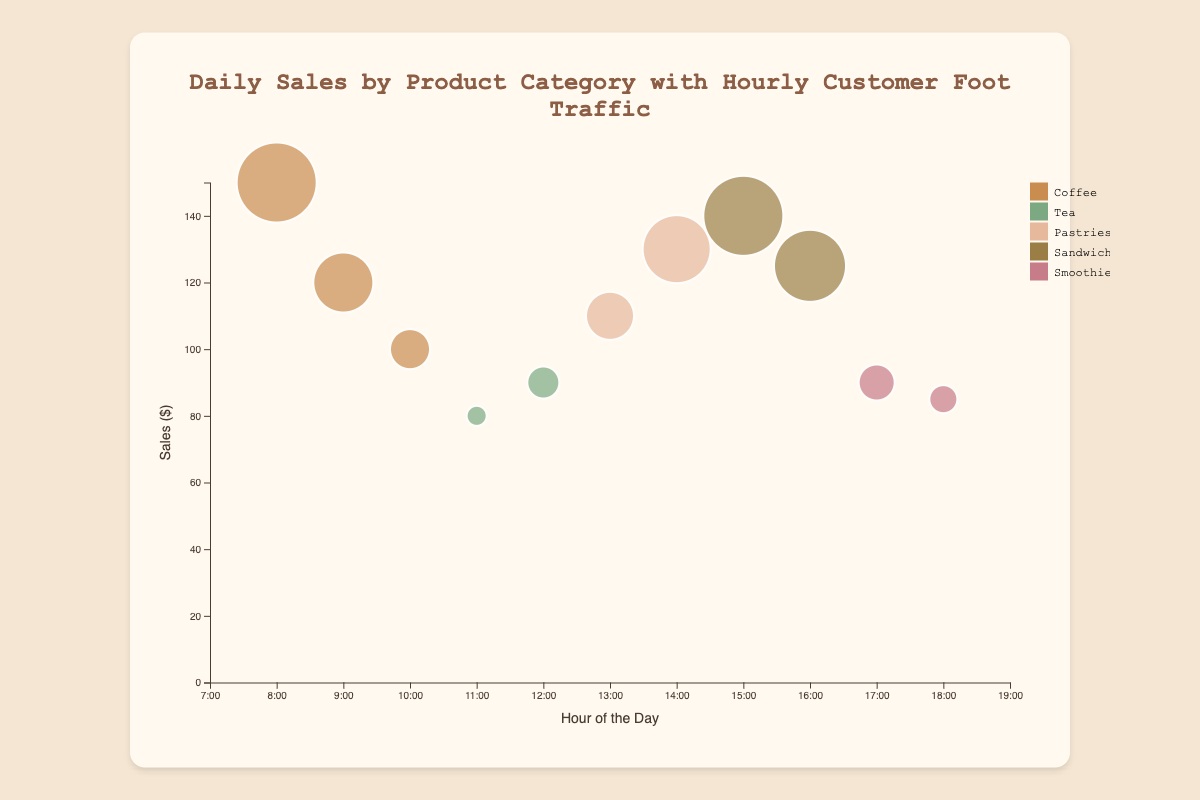What is the title of the chart? The title is usually located at the top of the chart and summarizes what the chart represents.
Answer: Daily Sales by Product Category with Hourly Customer Foot Traffic What does the horizontal axis represent? The horizontal axis at the bottom of the chart labels the data points on that axis. We can see it represents the hours of the day, ranging from 7:00 to 19:00.
Answer: Hour of the Day How many product categories are shown in the chart? By checking the legend on the right side of the chart, which lists the distinct categories, we see there are five different categories.
Answer: 5 In which hour did the highest sales occur, and which product was it for? By identifying the largest bubble along the vertical axis representing sales, at hour 8:00, we find that it's for Espresso with a sales value of $150.
Answer: 8:00 and Espresso Which category has the bubble with the largest radius and what does a larger radius indicate? The size of the bubble is related to customer traffic, and the largest bubble at hour 8:00 for Espresso falls under the Coffee category. Larger radius means higher customer traffic, here 30.
Answer: Coffee and higher customer traffic What are the total sales for the Coffee category? Combine the sales values for Espresso ($150), Latte ($120), and Cappuccino ($100) to get the total sales: $150 + $120 + $100 = $370.
Answer: $370 Which product had the least customer traffic, and how much was it? By checking the size of bubbles, the smallest bubble is at hour 11:00 for Green Tea, indicating the least customer traffic of 15.
Answer: Green Tea and 15 How do sales of pastries compare to sales of sandwiches? Add the sales of Croissant ($110) and Muffin ($130) to get pastries' sales ($240). Then add the sales of Ham Sandwich ($140) and Turkey Sandwich ($125) for sandwiches' sales ($265). Sandwiches' sales are higher.
Answer: Pastries: $240 and Sandwiches: $265 What's the average hourly customer traffic for all products? Sum all customer traffic values (30 + 25 + 20 + 15 + 18 + 22 + 27 + 30 + 28 + 19 + 17) to get 251 and divide by the number of hours (11). The average is 251/11 ≈ 22.8.
Answer: ≈ 22.8 Which hour has the highest customer traffic and what was the product? Identify the largest bubble radius on the horizontal axis. At hour 8:00 for Espresso has the highest customer traffic of 30.
Answer: 8:00 and Espresso 